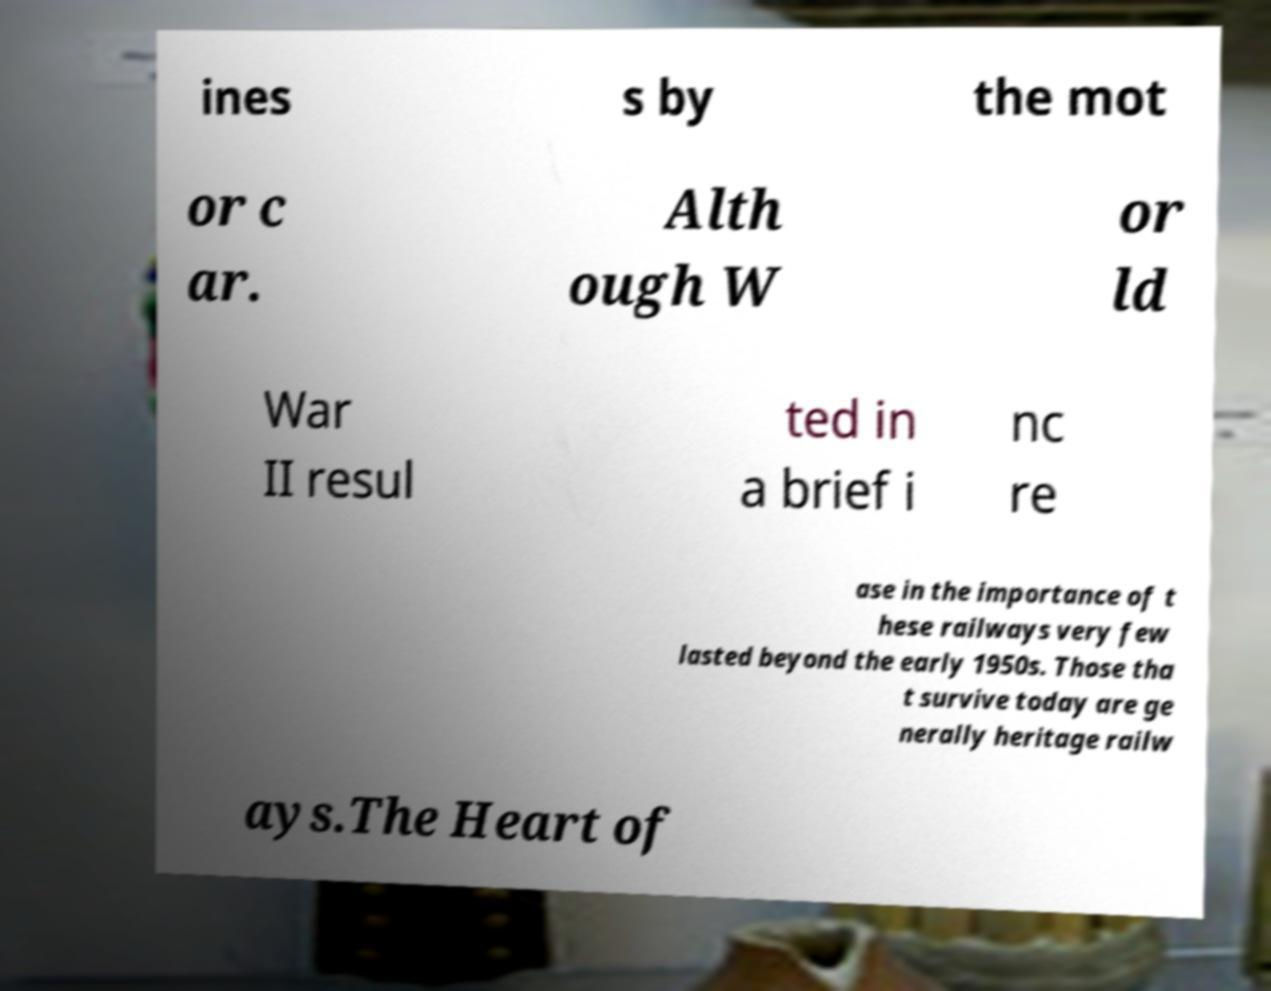For documentation purposes, I need the text within this image transcribed. Could you provide that? ines s by the mot or c ar. Alth ough W or ld War II resul ted in a brief i nc re ase in the importance of t hese railways very few lasted beyond the early 1950s. Those tha t survive today are ge nerally heritage railw ays.The Heart of 